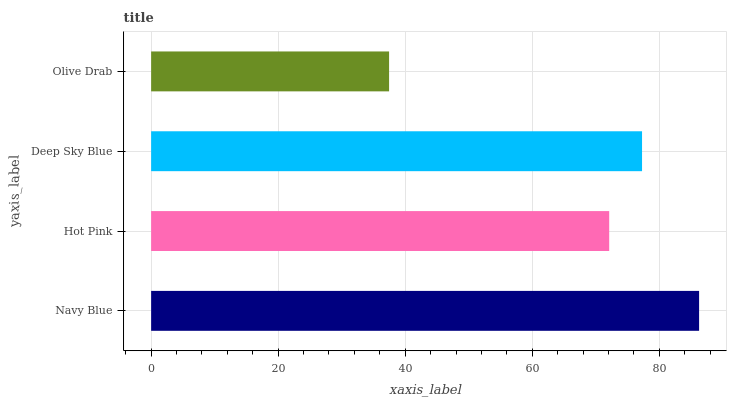Is Olive Drab the minimum?
Answer yes or no. Yes. Is Navy Blue the maximum?
Answer yes or no. Yes. Is Hot Pink the minimum?
Answer yes or no. No. Is Hot Pink the maximum?
Answer yes or no. No. Is Navy Blue greater than Hot Pink?
Answer yes or no. Yes. Is Hot Pink less than Navy Blue?
Answer yes or no. Yes. Is Hot Pink greater than Navy Blue?
Answer yes or no. No. Is Navy Blue less than Hot Pink?
Answer yes or no. No. Is Deep Sky Blue the high median?
Answer yes or no. Yes. Is Hot Pink the low median?
Answer yes or no. Yes. Is Olive Drab the high median?
Answer yes or no. No. Is Navy Blue the low median?
Answer yes or no. No. 